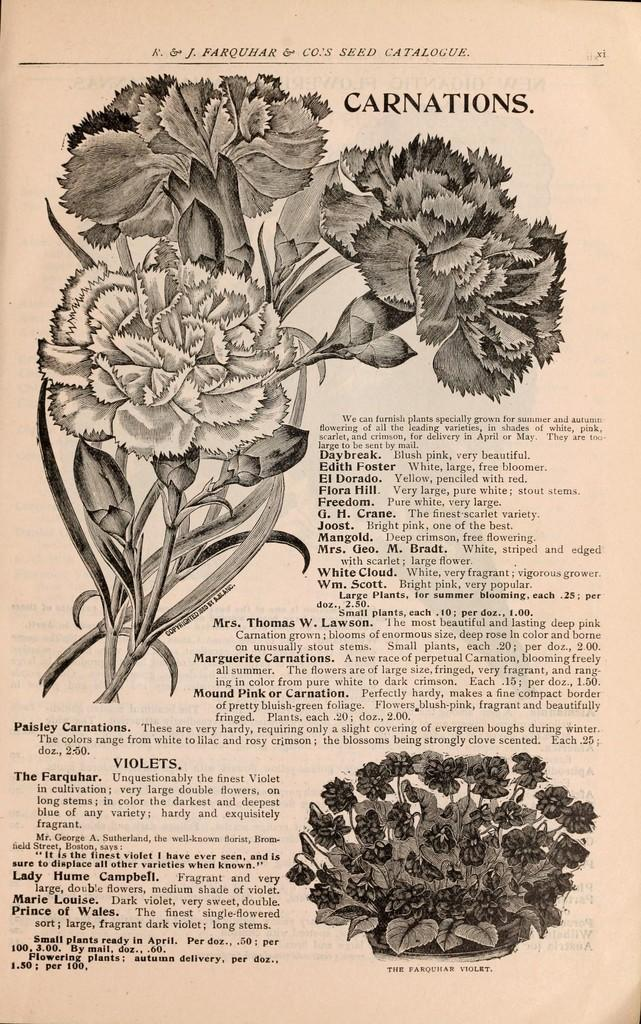What type of paper is visible in the image? There is a magazine paper in the image. What design or image is present on the magazine paper? The magazine paper has flowers on it. What can be found on the magazine paper besides the flowers? There is written matter on the magazine paper. How many ice cubes are present on the magazine paper? There are no ice cubes present on the magazine paper; it features a design with flowers and written matter. 